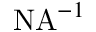Convert formula to latex. <formula><loc_0><loc_0><loc_500><loc_500>N A ^ { - 1 }</formula> 